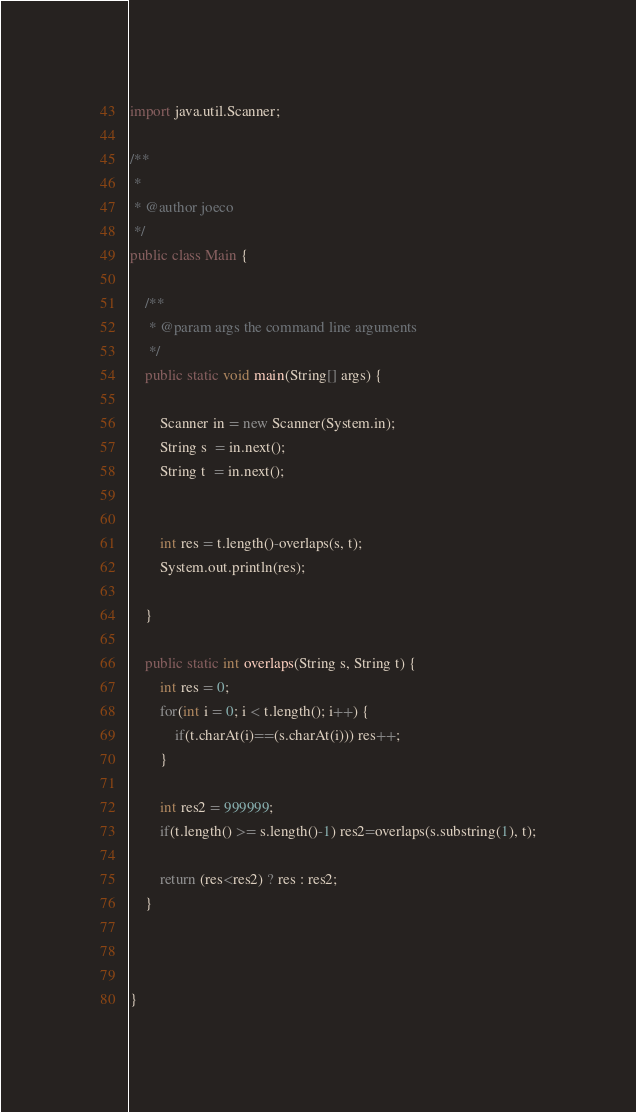Convert code to text. <code><loc_0><loc_0><loc_500><loc_500><_Java_>import java.util.Scanner;

/**
 *
 * @author joeco
 */
public class Main {

    /**
     * @param args the command line arguments
     */
    public static void main(String[] args) {
        
        Scanner in = new Scanner(System.in);
        String s  = in.next();
        String t  = in.next();
        
        
        int res = t.length()-overlaps(s, t);
        System.out.println(res);
        
    }
    
    public static int overlaps(String s, String t) {
        int res = 0;
        for(int i = 0; i < t.length(); i++) {
            if(t.charAt(i)==(s.charAt(i))) res++;
        }
        
        int res2 = 999999;
        if(t.length() >= s.length()-1) res2=overlaps(s.substring(1), t);
        
        return (res<res2) ? res : res2;
    }
    
    
    
}</code> 